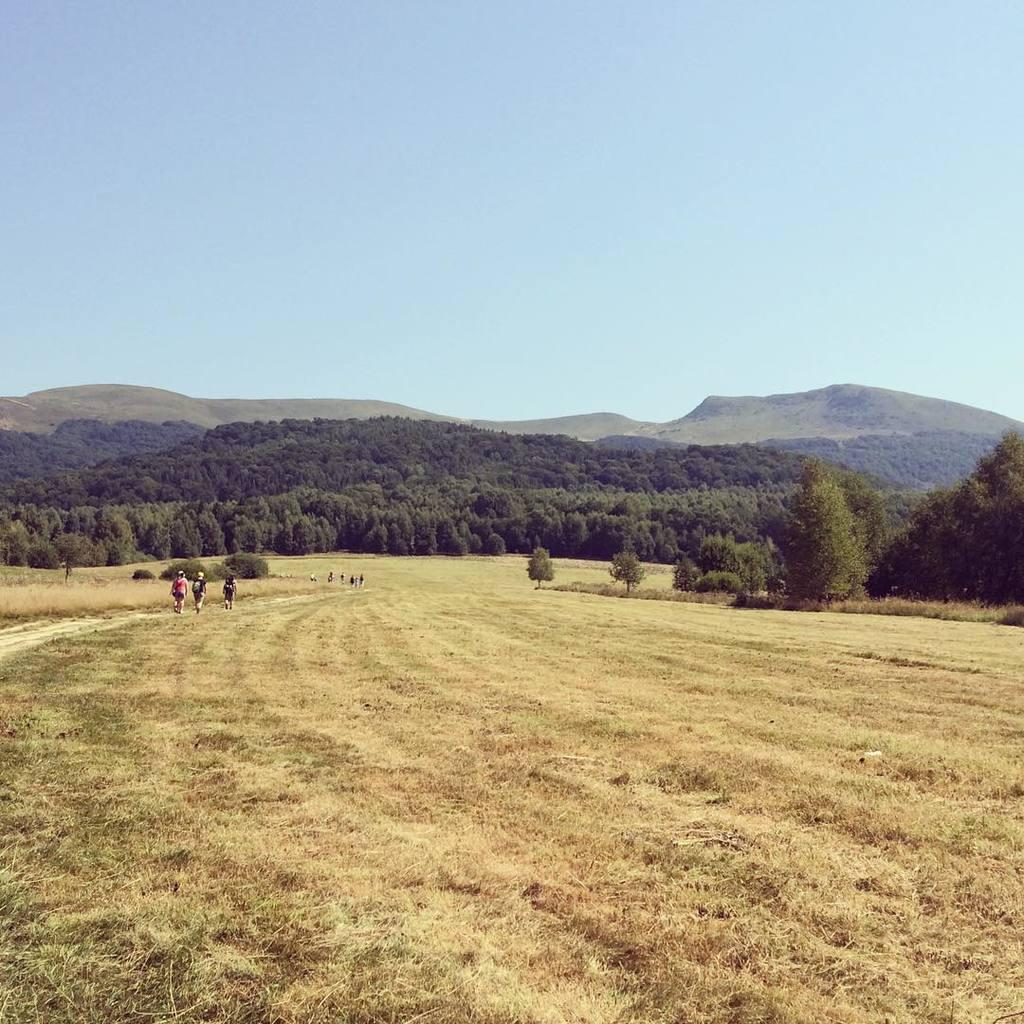What are the people in the image doing? The people in the image are walking on the ground. What type of vegetation can be seen in the image? There are trees and grass in the image. What geographical feature is visible in the background of the image? There are mountains in the image. What part of the natural environment is visible in the image? The sky is visible in the image. Can you see a tiger walking in the park in the image? There is no tiger or park present in the image. 